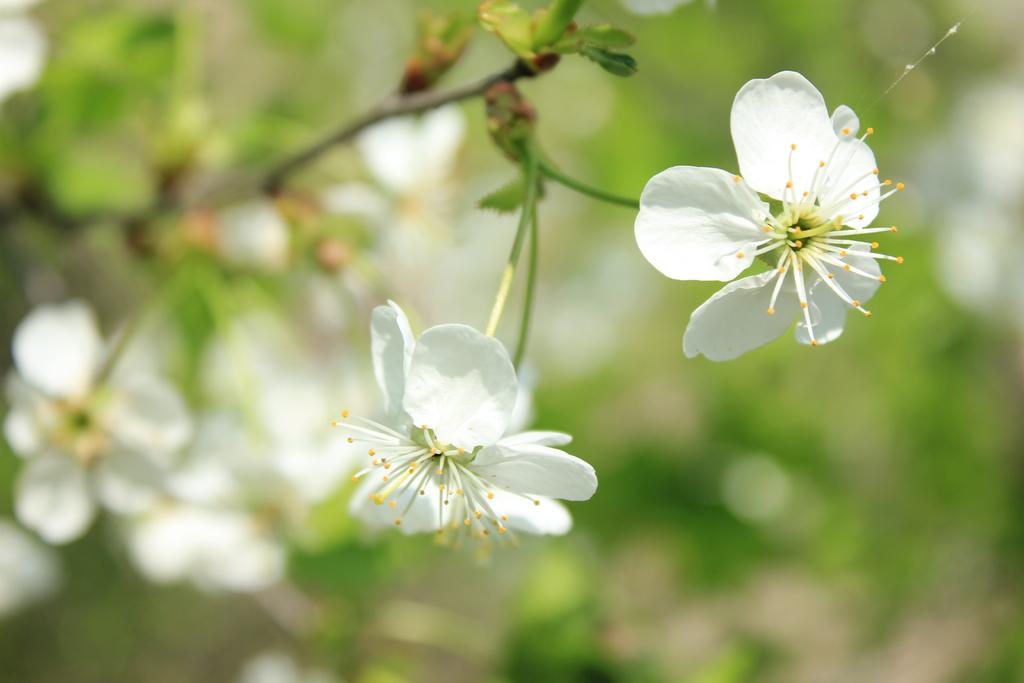What type of plants can be seen in the image? There are flowers in the image. What else can be seen in the background of the image? The background of the image includes leaves. How would you describe the appearance of the background? The background appears blurry. How many dimes are scattered among the flowers in the image? There are no dimes present in the image; it only features flowers and leaves. Can you see a person walking through the flowers in the image? There is no person visible in the image; it only features flowers and leaves. 